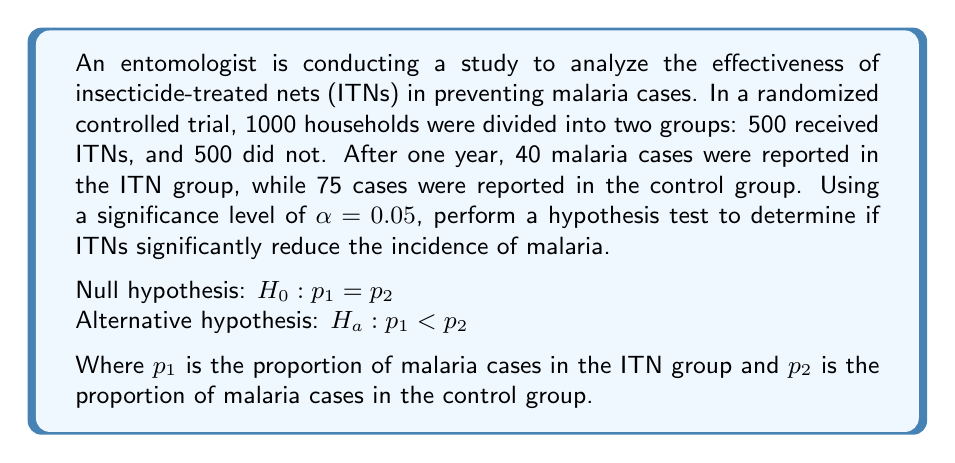Can you solve this math problem? To analyze the effectiveness of ITNs using statistical hypothesis testing, we'll perform a two-proportion z-test. We'll follow these steps:

1. Calculate the sample proportions:
   ITN group: $\hat{p}_1 = \frac{40}{500} = 0.08$
   Control group: $\hat{p}_2 = \frac{75}{500} = 0.15$

2. Calculate the pooled sample proportion:
   $$\hat{p} = \frac{X_1 + X_2}{n_1 + n_2} = \frac{40 + 75}{500 + 500} = \frac{115}{1000} = 0.115$$

3. Calculate the standard error of the difference between proportions:
   $$SE = \sqrt{\hat{p}(1-\hat{p})(\frac{1}{n_1} + \frac{1}{n_2})}$$
   $$SE = \sqrt{0.115(1-0.115)(\frac{1}{500} + \frac{1}{500})} = 0.0201$$

4. Calculate the z-score:
   $$z = \frac{(\hat{p}_1 - \hat{p}_2) - 0}{SE} = \frac{(0.08 - 0.15) - 0}{0.0201} = -3.4826$$

5. Find the p-value:
   Since this is a one-tailed test (we're testing if ITNs reduce malaria incidence), we need to find P(Z < -3.4826).
   Using a standard normal distribution table or calculator, we find:
   p-value = 0.0002477

6. Compare the p-value to the significance level:
   0.0002477 < 0.05

Since the p-value is less than the significance level, we reject the null hypothesis.
Answer: Reject the null hypothesis. There is sufficient evidence to conclude that insecticide-treated nets significantly reduce the incidence of malaria (p-value = 0.0002477 < 0.05). 